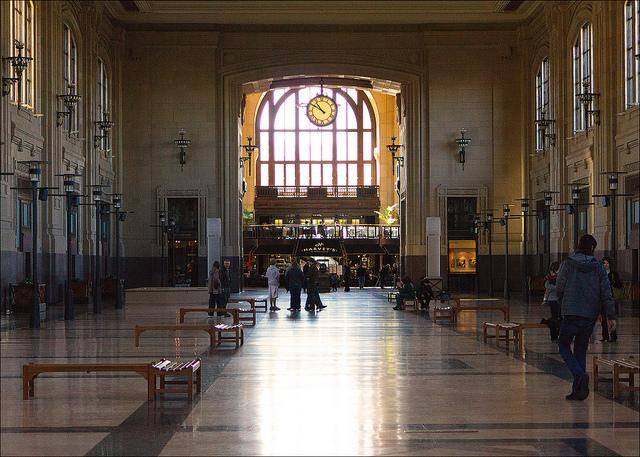What is on the left side of the room? Please explain your reasoning. bench. None of the other options make sense for this image. there are actually more than one of the a objects. 